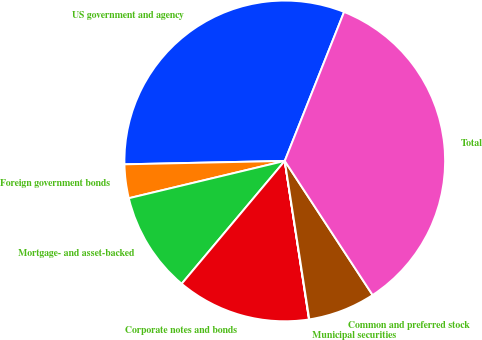Convert chart to OTSL. <chart><loc_0><loc_0><loc_500><loc_500><pie_chart><fcel>US government and agency<fcel>Foreign government bonds<fcel>Mortgage- and asset-backed<fcel>Corporate notes and bonds<fcel>Municipal securities<fcel>Common and preferred stock<fcel>Total<nl><fcel>31.37%<fcel>3.4%<fcel>10.15%<fcel>13.53%<fcel>0.03%<fcel>6.78%<fcel>34.74%<nl></chart> 